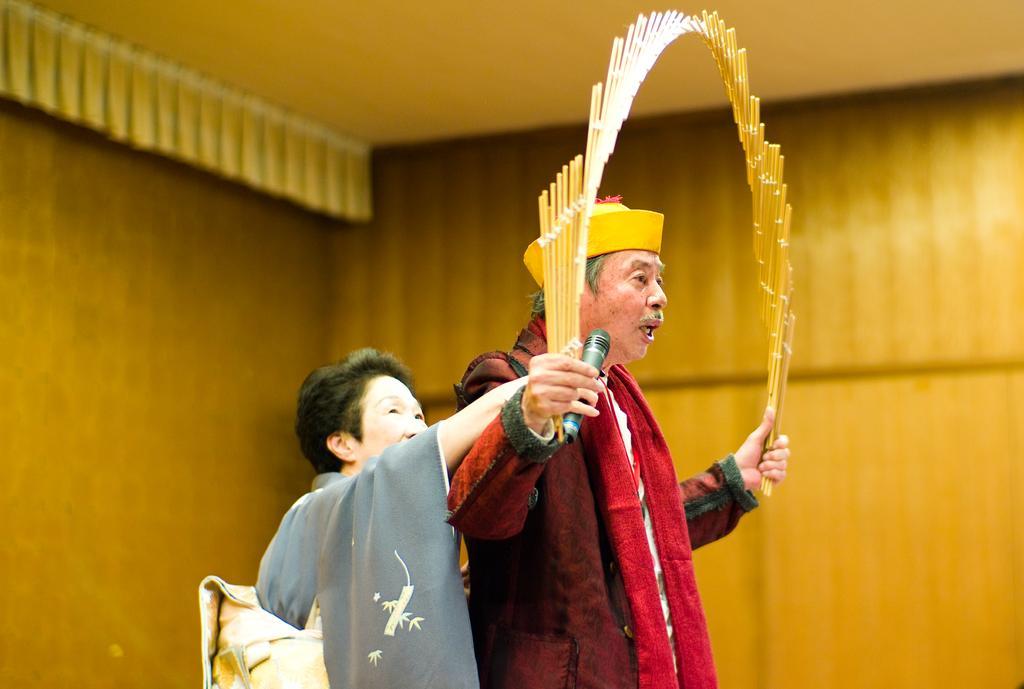How would you summarize this image in a sentence or two? In this image in front there are two persons where one person is holding the mike and some object. In the background of the image there is a wall. 